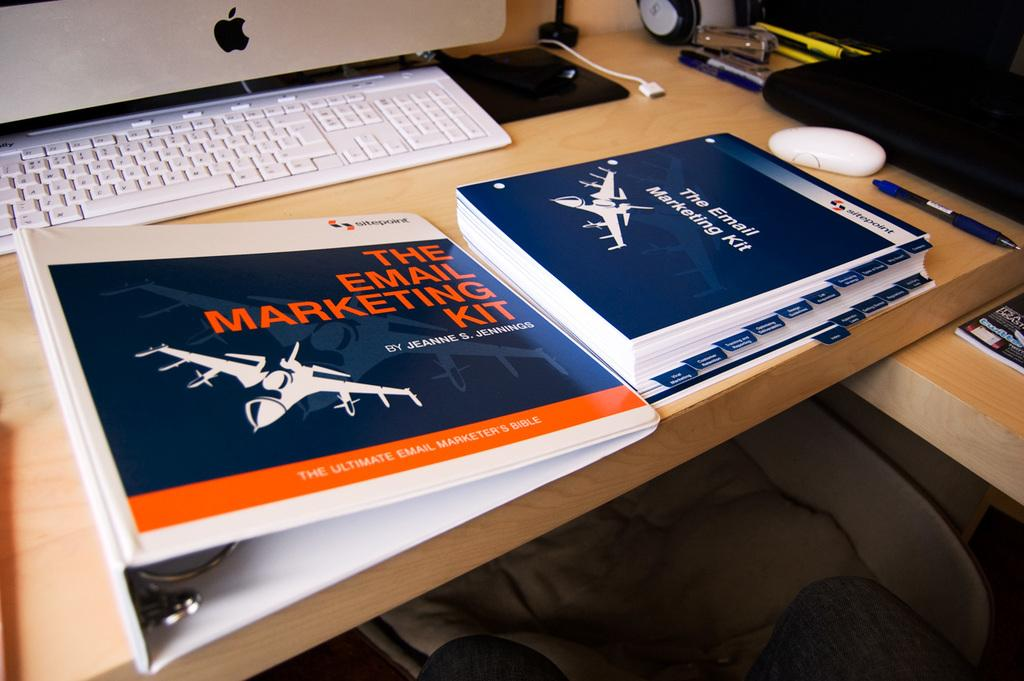Provide a one-sentence caption for the provided image. A folder on a desk labeled "the email marketing kit - the ultimate email marketing bible.". 